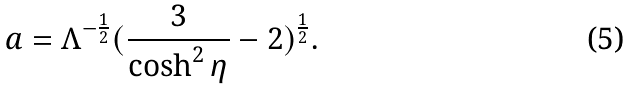Convert formula to latex. <formula><loc_0><loc_0><loc_500><loc_500>a = \Lambda ^ { - \frac { 1 } { 2 } } ( \frac { 3 } { \cosh ^ { 2 } \eta } - 2 ) ^ { \frac { 1 } { 2 } } .</formula> 